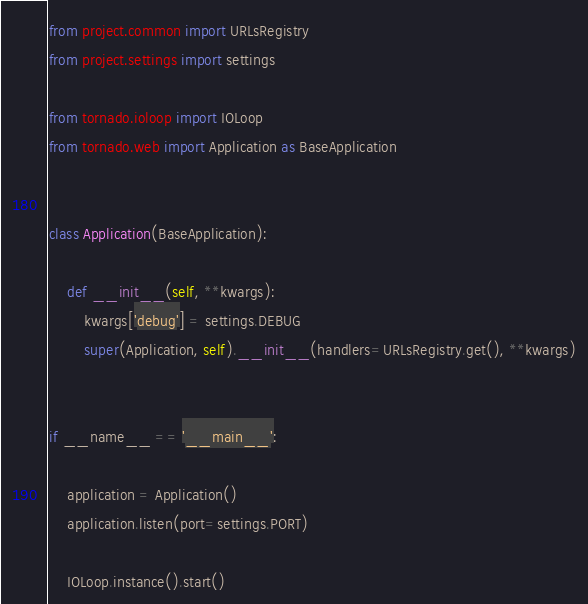<code> <loc_0><loc_0><loc_500><loc_500><_Python_>from project.common import URLsRegistry
from project.settings import settings

from tornado.ioloop import IOLoop
from tornado.web import Application as BaseApplication


class Application(BaseApplication):

    def __init__(self, **kwargs):
        kwargs['debug'] = settings.DEBUG
        super(Application, self).__init__(handlers=URLsRegistry.get(), **kwargs)


if __name__ == '__main__':

    application = Application()
    application.listen(port=settings.PORT)

    IOLoop.instance().start()
</code> 